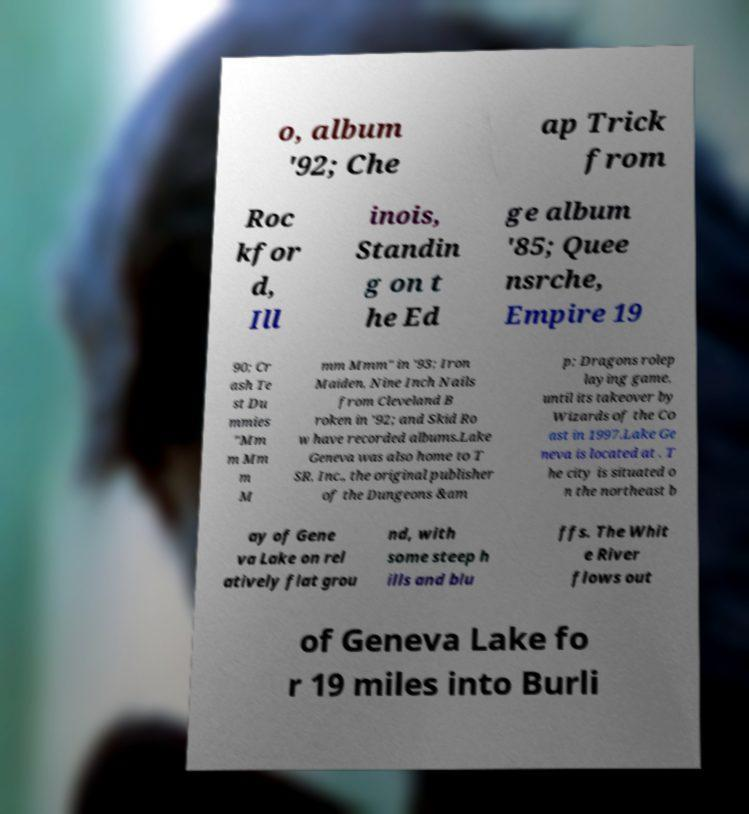Can you read and provide the text displayed in the image?This photo seems to have some interesting text. Can you extract and type it out for me? o, album '92; Che ap Trick from Roc kfor d, Ill inois, Standin g on t he Ed ge album '85; Quee nsrche, Empire 19 90; Cr ash Te st Du mmies "Mm m Mm m M mm Mmm" in '93; Iron Maiden, Nine Inch Nails from Cleveland B roken in '92; and Skid Ro w have recorded albums.Lake Geneva was also home to T SR, Inc., the original publisher of the Dungeons &am p; Dragons rolep laying game, until its takeover by Wizards of the Co ast in 1997.Lake Ge neva is located at . T he city is situated o n the northeast b ay of Gene va Lake on rel atively flat grou nd, with some steep h ills and blu ffs. The Whit e River flows out of Geneva Lake fo r 19 miles into Burli 